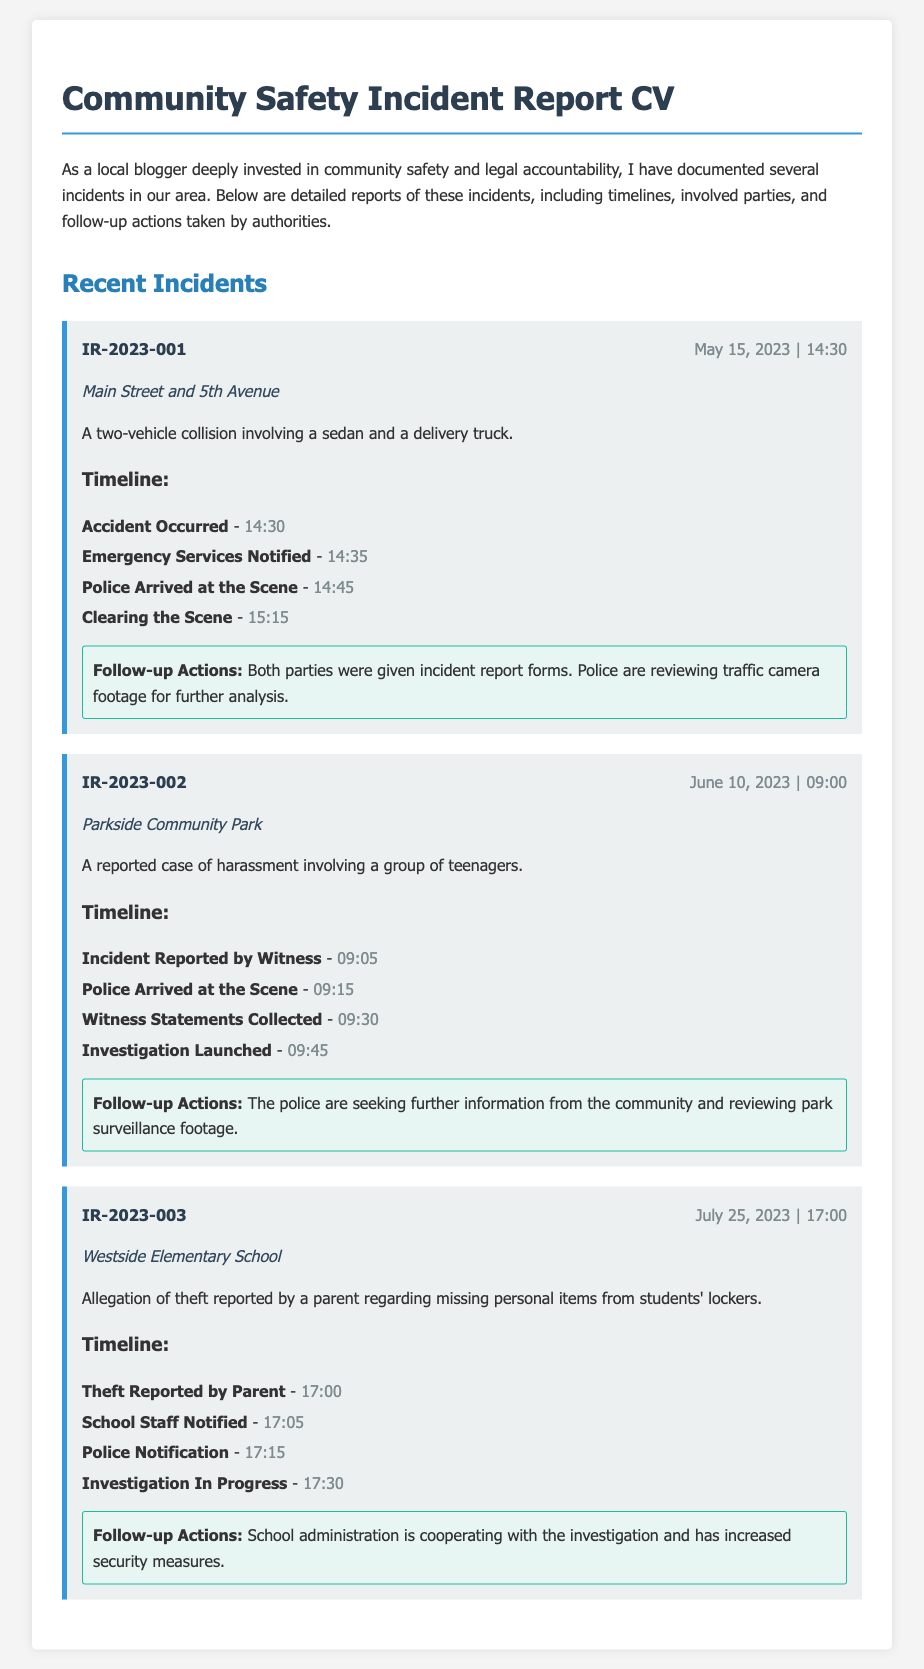What is the incident ID for the first report? The incident ID for the first report is found at the top of the report, which states IR-2023-001.
Answer: IR-2023-001 What location is mentioned in the second incident report? The location is specified within the details of the incident, which is Parkside Community Park.
Answer: Parkside Community Park What was the time of the theft report in the third incident? The time is stated in the timeline of the incident, which is 17:00.
Answer: 17:00 How many incidents are detailed in the document? The total number of incidents is indicated in the section titled Recent Incidents, showing three separate reports.
Answer: Three What action was taken after the accident occurred in the first incident? The timeline mentions that emergency services were notified shortly after the accident occurred at 14:30.
Answer: Emergency Services Notified Which incident involved harassment? The incident involving harassment is indicated specifically in the second report about a case of harassment with teenagers.
Answer: A reported case of harassment What was the follow-up action for the theft at Westside Elementary? The follow-up action stated that school administration is cooperating with the investigation and increasing security measures.
Answer: Increased security measures When did the police arrive at the scene of the second incident? The arrival time of the police is noted within the timeline, which states they arrived at 09:15.
Answer: 09:15 